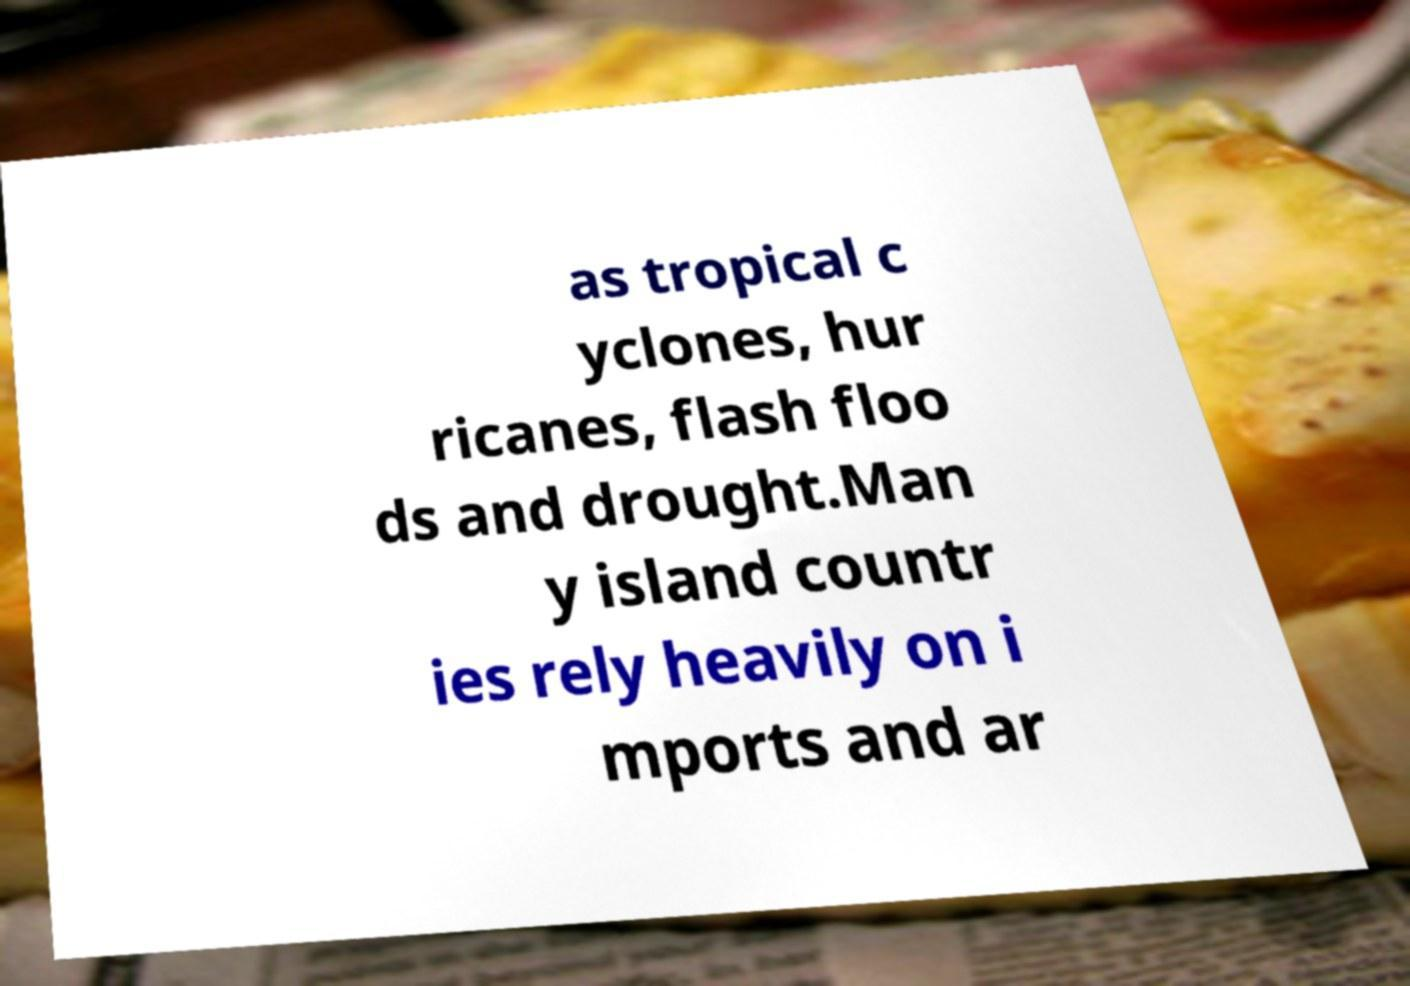What messages or text are displayed in this image? I need them in a readable, typed format. as tropical c yclones, hur ricanes, flash floo ds and drought.Man y island countr ies rely heavily on i mports and ar 